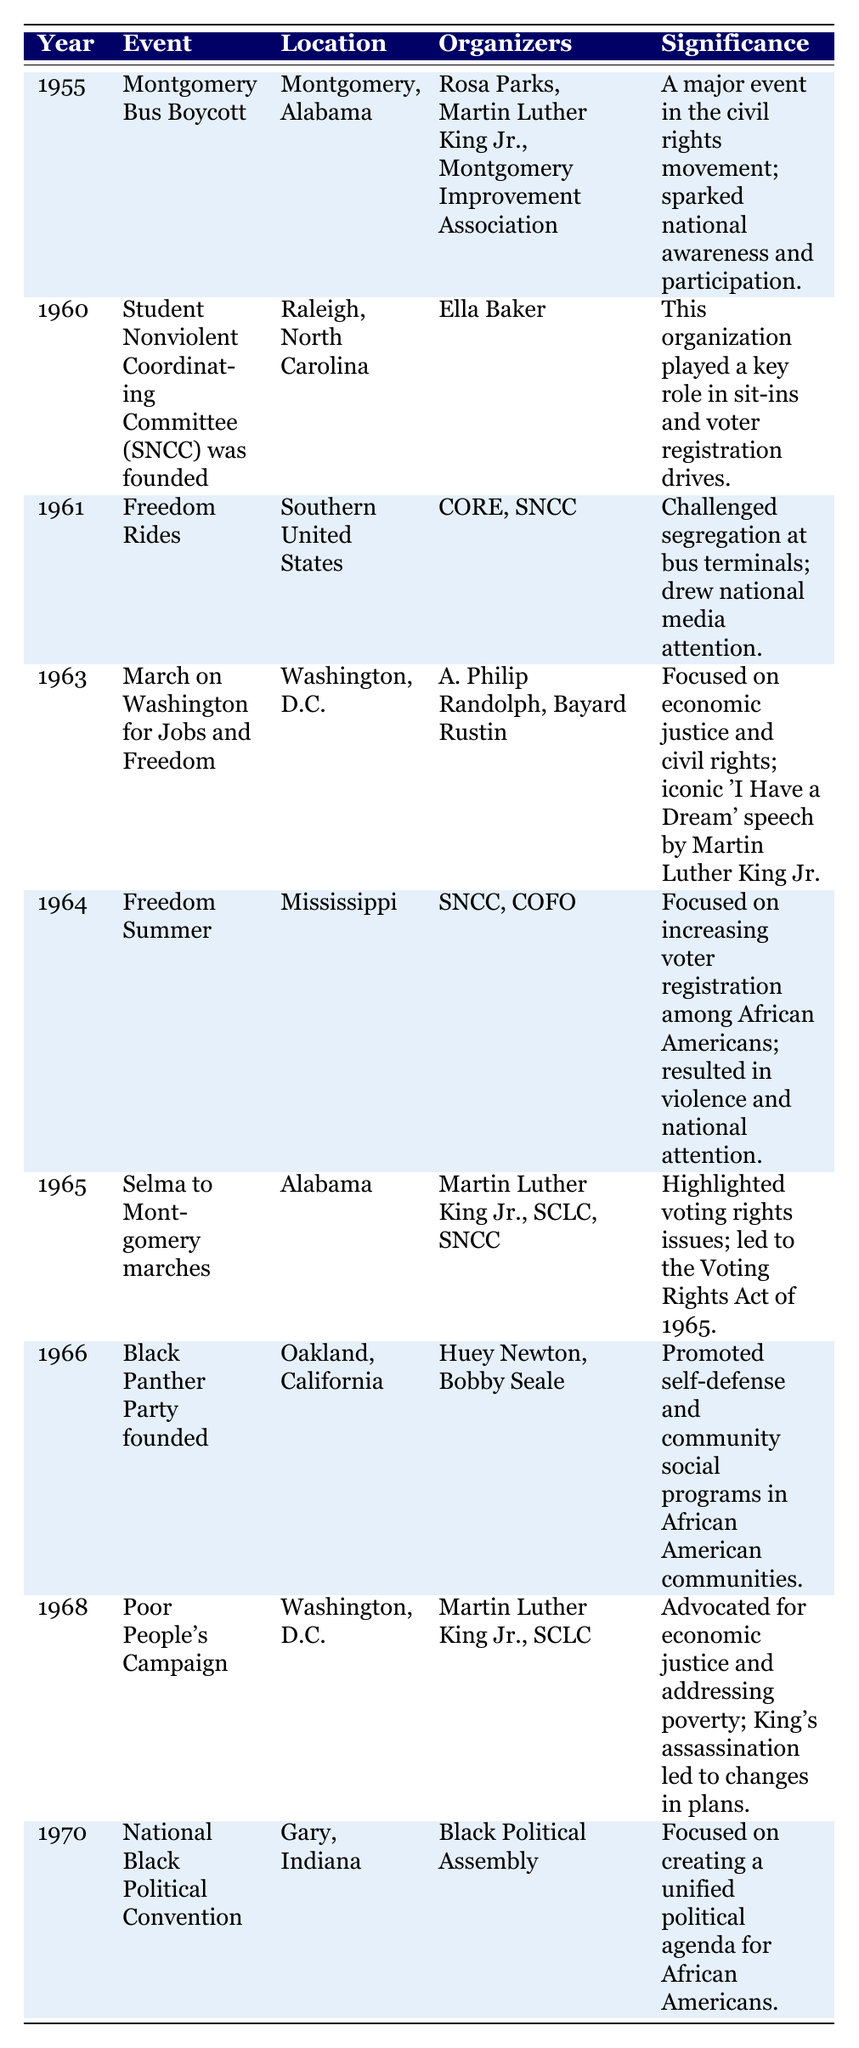What event took place in 1963? The table lists the event that took place in 1963 as the "March on Washington for Jobs and Freedom."
Answer: March on Washington for Jobs and Freedom Which organizers were involved in the Freedom Rides? According to the table, the Freedom Rides were organized by CORE and SNCC.
Answer: CORE and SNCC Was the Black Panther Party founded before or after 1965? By looking at the table, it can be observed that the Black Panther Party was founded in 1966, which is after 1965.
Answer: After How many events are listed in the table for the year 1960? The table has only one event listed for the year 1960, which is the founding of the SNCC.
Answer: 1 What is the significance of the Selma to Montgomery marches? The table states that the Selma to Montgomery marches highlighted voting rights issues and led to the Voting Rights Act of 1965.
Answer: Highlighted voting rights issues Which event had the highest level of organizer participation? To determine the event with the highest level of organizer participation, we can compare the number of organizers for each event; the "Montgomery Bus Boycott" and "Selma to Montgomery marches" have three organizers, but "Black Panther Party founded" has two. The answer requires identifying those with the most, which is "Montgomery Bus Boycott" and "Selma to Montgomery marches."
Answer: Montgomery Bus Boycott and Selma to Montgomery marches What is the difference in years between the founding of SNCC and the Poor People's Campaign? The SNCC was founded in 1960 and the Poor People's Campaign occurred in 1968. The difference in years is 1968 - 1960 = 8 years.
Answer: 8 years Was the March on Washington organized solely by A. Philip Randolph? Looking at the table, it shows that the March on Washington was organized by A. Philip Randolph and Bayard Rustin, indicating it was not organized solely by one individual.
Answer: No Which event focused on economic justice and civil rights? The table indicates that the "March on Washington for Jobs and Freedom" focused on economic justice and civil rights.
Answer: March on Washington for Jobs and Freedom What is the trend of grassroots events from 1955 to 1970? To determine the trend, we can observe that there is a steady increase in the number of notable grassroots events occurring throughout the civil rights movement between 1955 and 1970; the movement evolved and focused on different aspects of civil rights over these years.
Answer: Increasing activity List all locations where significant events occurred during the civil rights movement as per the table. By scanning the table, the locations mentioned are Montgomery, Alabama; Raleigh, North Carolina; Southern United States; Washington, D.C.; Mississippi; Alabama; Oakland, California; and Gary, Indiana. These locations were key sites of significant grassroots events.
Answer: Montgomery, Alabama; Raleigh, North Carolina; Southern United States; Washington, D.C.; Mississippi; Alabama; Oakland, California; Gary, Indiana From the data provided, how many events took place in Washington, D.C.? In the table, there are two events listed in Washington, D.C.: the "March on Washington for Jobs and Freedom" in 1963 and the "Poor People's Campaign" in 1968, totaling two events in that location.
Answer: 2 